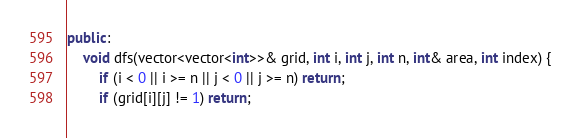Convert code to text. <code><loc_0><loc_0><loc_500><loc_500><_C++_>public:
    void dfs(vector<vector<int>>& grid, int i, int j, int n, int& area, int index) {
        if (i < 0 || i >= n || j < 0 || j >= n) return;
        if (grid[i][j] != 1) return;</code> 